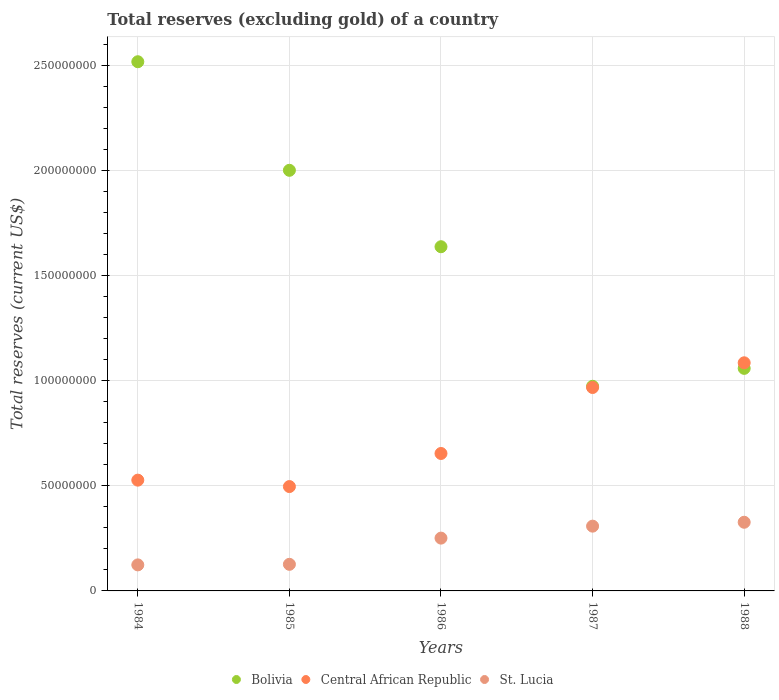How many different coloured dotlines are there?
Offer a very short reply. 3. Is the number of dotlines equal to the number of legend labels?
Your answer should be compact. Yes. What is the total reserves (excluding gold) in St. Lucia in 1987?
Offer a very short reply. 3.08e+07. Across all years, what is the maximum total reserves (excluding gold) in Bolivia?
Your response must be concise. 2.52e+08. Across all years, what is the minimum total reserves (excluding gold) in Bolivia?
Your answer should be very brief. 9.73e+07. In which year was the total reserves (excluding gold) in St. Lucia maximum?
Offer a terse response. 1988. What is the total total reserves (excluding gold) in Central African Republic in the graph?
Give a very brief answer. 3.73e+08. What is the difference between the total reserves (excluding gold) in St. Lucia in 1985 and that in 1986?
Offer a terse response. -1.25e+07. What is the difference between the total reserves (excluding gold) in St. Lucia in 1985 and the total reserves (excluding gold) in Bolivia in 1987?
Your answer should be compact. -8.47e+07. What is the average total reserves (excluding gold) in Central African Republic per year?
Provide a succinct answer. 7.46e+07. In the year 1987, what is the difference between the total reserves (excluding gold) in Bolivia and total reserves (excluding gold) in St. Lucia?
Your answer should be very brief. 6.65e+07. What is the ratio of the total reserves (excluding gold) in Central African Republic in 1984 to that in 1988?
Make the answer very short. 0.49. Is the total reserves (excluding gold) in Bolivia in 1984 less than that in 1988?
Keep it short and to the point. No. Is the difference between the total reserves (excluding gold) in Bolivia in 1984 and 1986 greater than the difference between the total reserves (excluding gold) in St. Lucia in 1984 and 1986?
Keep it short and to the point. Yes. What is the difference between the highest and the second highest total reserves (excluding gold) in Central African Republic?
Your answer should be very brief. 1.17e+07. What is the difference between the highest and the lowest total reserves (excluding gold) in St. Lucia?
Ensure brevity in your answer.  2.03e+07. Is the sum of the total reserves (excluding gold) in Bolivia in 1984 and 1987 greater than the maximum total reserves (excluding gold) in St. Lucia across all years?
Offer a very short reply. Yes. Is the total reserves (excluding gold) in Central African Republic strictly less than the total reserves (excluding gold) in Bolivia over the years?
Make the answer very short. No. Where does the legend appear in the graph?
Provide a succinct answer. Bottom center. How many legend labels are there?
Your response must be concise. 3. What is the title of the graph?
Ensure brevity in your answer.  Total reserves (excluding gold) of a country. What is the label or title of the X-axis?
Your response must be concise. Years. What is the label or title of the Y-axis?
Give a very brief answer. Total reserves (current US$). What is the Total reserves (current US$) of Bolivia in 1984?
Offer a very short reply. 2.52e+08. What is the Total reserves (current US$) of Central African Republic in 1984?
Offer a very short reply. 5.27e+07. What is the Total reserves (current US$) in St. Lucia in 1984?
Ensure brevity in your answer.  1.24e+07. What is the Total reserves (current US$) of Bolivia in 1985?
Make the answer very short. 2.00e+08. What is the Total reserves (current US$) of Central African Republic in 1985?
Offer a terse response. 4.96e+07. What is the Total reserves (current US$) in St. Lucia in 1985?
Your answer should be compact. 1.26e+07. What is the Total reserves (current US$) of Bolivia in 1986?
Make the answer very short. 1.64e+08. What is the Total reserves (current US$) in Central African Republic in 1986?
Give a very brief answer. 6.54e+07. What is the Total reserves (current US$) in St. Lucia in 1986?
Your answer should be very brief. 2.51e+07. What is the Total reserves (current US$) in Bolivia in 1987?
Your answer should be very brief. 9.73e+07. What is the Total reserves (current US$) in Central African Republic in 1987?
Give a very brief answer. 9.67e+07. What is the Total reserves (current US$) of St. Lucia in 1987?
Your answer should be very brief. 3.08e+07. What is the Total reserves (current US$) of Bolivia in 1988?
Make the answer very short. 1.06e+08. What is the Total reserves (current US$) of Central African Republic in 1988?
Provide a succinct answer. 1.08e+08. What is the Total reserves (current US$) in St. Lucia in 1988?
Provide a succinct answer. 3.26e+07. Across all years, what is the maximum Total reserves (current US$) in Bolivia?
Give a very brief answer. 2.52e+08. Across all years, what is the maximum Total reserves (current US$) in Central African Republic?
Provide a succinct answer. 1.08e+08. Across all years, what is the maximum Total reserves (current US$) in St. Lucia?
Your response must be concise. 3.26e+07. Across all years, what is the minimum Total reserves (current US$) of Bolivia?
Your answer should be compact. 9.73e+07. Across all years, what is the minimum Total reserves (current US$) of Central African Republic?
Offer a very short reply. 4.96e+07. Across all years, what is the minimum Total reserves (current US$) of St. Lucia?
Make the answer very short. 1.24e+07. What is the total Total reserves (current US$) of Bolivia in the graph?
Your answer should be very brief. 8.18e+08. What is the total Total reserves (current US$) in Central African Republic in the graph?
Your answer should be very brief. 3.73e+08. What is the total Total reserves (current US$) of St. Lucia in the graph?
Provide a succinct answer. 1.14e+08. What is the difference between the Total reserves (current US$) of Bolivia in 1984 and that in 1985?
Give a very brief answer. 5.16e+07. What is the difference between the Total reserves (current US$) in Central African Republic in 1984 and that in 1985?
Offer a terse response. 3.05e+06. What is the difference between the Total reserves (current US$) in St. Lucia in 1984 and that in 1985?
Your response must be concise. -2.70e+05. What is the difference between the Total reserves (current US$) of Bolivia in 1984 and that in 1986?
Offer a terse response. 8.80e+07. What is the difference between the Total reserves (current US$) in Central African Republic in 1984 and that in 1986?
Ensure brevity in your answer.  -1.27e+07. What is the difference between the Total reserves (current US$) of St. Lucia in 1984 and that in 1986?
Make the answer very short. -1.27e+07. What is the difference between the Total reserves (current US$) of Bolivia in 1984 and that in 1987?
Offer a very short reply. 1.54e+08. What is the difference between the Total reserves (current US$) of Central African Republic in 1984 and that in 1987?
Offer a very short reply. -4.41e+07. What is the difference between the Total reserves (current US$) in St. Lucia in 1984 and that in 1987?
Offer a terse response. -1.84e+07. What is the difference between the Total reserves (current US$) in Bolivia in 1984 and that in 1988?
Offer a very short reply. 1.46e+08. What is the difference between the Total reserves (current US$) in Central African Republic in 1984 and that in 1988?
Your response must be concise. -5.58e+07. What is the difference between the Total reserves (current US$) in St. Lucia in 1984 and that in 1988?
Offer a terse response. -2.03e+07. What is the difference between the Total reserves (current US$) in Bolivia in 1985 and that in 1986?
Ensure brevity in your answer.  3.63e+07. What is the difference between the Total reserves (current US$) of Central African Republic in 1985 and that in 1986?
Offer a very short reply. -1.57e+07. What is the difference between the Total reserves (current US$) of St. Lucia in 1985 and that in 1986?
Your response must be concise. -1.25e+07. What is the difference between the Total reserves (current US$) of Bolivia in 1985 and that in 1987?
Your answer should be compact. 1.03e+08. What is the difference between the Total reserves (current US$) in Central African Republic in 1985 and that in 1987?
Keep it short and to the point. -4.71e+07. What is the difference between the Total reserves (current US$) in St. Lucia in 1985 and that in 1987?
Ensure brevity in your answer.  -1.82e+07. What is the difference between the Total reserves (current US$) of Bolivia in 1985 and that in 1988?
Keep it short and to the point. 9.42e+07. What is the difference between the Total reserves (current US$) in Central African Republic in 1985 and that in 1988?
Your answer should be compact. -5.89e+07. What is the difference between the Total reserves (current US$) in St. Lucia in 1985 and that in 1988?
Your answer should be very brief. -2.00e+07. What is the difference between the Total reserves (current US$) in Bolivia in 1986 and that in 1987?
Keep it short and to the point. 6.64e+07. What is the difference between the Total reserves (current US$) of Central African Republic in 1986 and that in 1987?
Offer a very short reply. -3.14e+07. What is the difference between the Total reserves (current US$) of St. Lucia in 1986 and that in 1987?
Your answer should be very brief. -5.69e+06. What is the difference between the Total reserves (current US$) of Bolivia in 1986 and that in 1988?
Offer a very short reply. 5.78e+07. What is the difference between the Total reserves (current US$) of Central African Republic in 1986 and that in 1988?
Ensure brevity in your answer.  -4.31e+07. What is the difference between the Total reserves (current US$) in St. Lucia in 1986 and that in 1988?
Provide a short and direct response. -7.54e+06. What is the difference between the Total reserves (current US$) in Bolivia in 1987 and that in 1988?
Offer a very short reply. -8.51e+06. What is the difference between the Total reserves (current US$) of Central African Republic in 1987 and that in 1988?
Make the answer very short. -1.17e+07. What is the difference between the Total reserves (current US$) of St. Lucia in 1987 and that in 1988?
Provide a succinct answer. -1.85e+06. What is the difference between the Total reserves (current US$) in Bolivia in 1984 and the Total reserves (current US$) in Central African Republic in 1985?
Give a very brief answer. 2.02e+08. What is the difference between the Total reserves (current US$) of Bolivia in 1984 and the Total reserves (current US$) of St. Lucia in 1985?
Your response must be concise. 2.39e+08. What is the difference between the Total reserves (current US$) in Central African Republic in 1984 and the Total reserves (current US$) in St. Lucia in 1985?
Your response must be concise. 4.00e+07. What is the difference between the Total reserves (current US$) of Bolivia in 1984 and the Total reserves (current US$) of Central African Republic in 1986?
Keep it short and to the point. 1.86e+08. What is the difference between the Total reserves (current US$) of Bolivia in 1984 and the Total reserves (current US$) of St. Lucia in 1986?
Offer a very short reply. 2.27e+08. What is the difference between the Total reserves (current US$) in Central African Republic in 1984 and the Total reserves (current US$) in St. Lucia in 1986?
Provide a succinct answer. 2.76e+07. What is the difference between the Total reserves (current US$) in Bolivia in 1984 and the Total reserves (current US$) in Central African Republic in 1987?
Your response must be concise. 1.55e+08. What is the difference between the Total reserves (current US$) of Bolivia in 1984 and the Total reserves (current US$) of St. Lucia in 1987?
Give a very brief answer. 2.21e+08. What is the difference between the Total reserves (current US$) in Central African Republic in 1984 and the Total reserves (current US$) in St. Lucia in 1987?
Give a very brief answer. 2.19e+07. What is the difference between the Total reserves (current US$) in Bolivia in 1984 and the Total reserves (current US$) in Central African Republic in 1988?
Offer a very short reply. 1.43e+08. What is the difference between the Total reserves (current US$) in Bolivia in 1984 and the Total reserves (current US$) in St. Lucia in 1988?
Ensure brevity in your answer.  2.19e+08. What is the difference between the Total reserves (current US$) of Central African Republic in 1984 and the Total reserves (current US$) of St. Lucia in 1988?
Keep it short and to the point. 2.00e+07. What is the difference between the Total reserves (current US$) in Bolivia in 1985 and the Total reserves (current US$) in Central African Republic in 1986?
Your answer should be compact. 1.35e+08. What is the difference between the Total reserves (current US$) in Bolivia in 1985 and the Total reserves (current US$) in St. Lucia in 1986?
Your answer should be very brief. 1.75e+08. What is the difference between the Total reserves (current US$) in Central African Republic in 1985 and the Total reserves (current US$) in St. Lucia in 1986?
Offer a very short reply. 2.45e+07. What is the difference between the Total reserves (current US$) in Bolivia in 1985 and the Total reserves (current US$) in Central African Republic in 1987?
Give a very brief answer. 1.03e+08. What is the difference between the Total reserves (current US$) of Bolivia in 1985 and the Total reserves (current US$) of St. Lucia in 1987?
Your answer should be very brief. 1.69e+08. What is the difference between the Total reserves (current US$) of Central African Republic in 1985 and the Total reserves (current US$) of St. Lucia in 1987?
Give a very brief answer. 1.88e+07. What is the difference between the Total reserves (current US$) of Bolivia in 1985 and the Total reserves (current US$) of Central African Republic in 1988?
Give a very brief answer. 9.15e+07. What is the difference between the Total reserves (current US$) of Bolivia in 1985 and the Total reserves (current US$) of St. Lucia in 1988?
Offer a very short reply. 1.67e+08. What is the difference between the Total reserves (current US$) of Central African Republic in 1985 and the Total reserves (current US$) of St. Lucia in 1988?
Make the answer very short. 1.70e+07. What is the difference between the Total reserves (current US$) in Bolivia in 1986 and the Total reserves (current US$) in Central African Republic in 1987?
Provide a short and direct response. 6.69e+07. What is the difference between the Total reserves (current US$) of Bolivia in 1986 and the Total reserves (current US$) of St. Lucia in 1987?
Ensure brevity in your answer.  1.33e+08. What is the difference between the Total reserves (current US$) of Central African Republic in 1986 and the Total reserves (current US$) of St. Lucia in 1987?
Your response must be concise. 3.46e+07. What is the difference between the Total reserves (current US$) in Bolivia in 1986 and the Total reserves (current US$) in Central African Republic in 1988?
Provide a succinct answer. 5.52e+07. What is the difference between the Total reserves (current US$) of Bolivia in 1986 and the Total reserves (current US$) of St. Lucia in 1988?
Give a very brief answer. 1.31e+08. What is the difference between the Total reserves (current US$) of Central African Republic in 1986 and the Total reserves (current US$) of St. Lucia in 1988?
Offer a very short reply. 3.27e+07. What is the difference between the Total reserves (current US$) in Bolivia in 1987 and the Total reserves (current US$) in Central African Republic in 1988?
Provide a short and direct response. -1.12e+07. What is the difference between the Total reserves (current US$) of Bolivia in 1987 and the Total reserves (current US$) of St. Lucia in 1988?
Make the answer very short. 6.47e+07. What is the difference between the Total reserves (current US$) in Central African Republic in 1987 and the Total reserves (current US$) in St. Lucia in 1988?
Offer a terse response. 6.41e+07. What is the average Total reserves (current US$) of Bolivia per year?
Make the answer very short. 1.64e+08. What is the average Total reserves (current US$) of Central African Republic per year?
Keep it short and to the point. 7.46e+07. What is the average Total reserves (current US$) in St. Lucia per year?
Keep it short and to the point. 2.27e+07. In the year 1984, what is the difference between the Total reserves (current US$) of Bolivia and Total reserves (current US$) of Central African Republic?
Keep it short and to the point. 1.99e+08. In the year 1984, what is the difference between the Total reserves (current US$) of Bolivia and Total reserves (current US$) of St. Lucia?
Give a very brief answer. 2.39e+08. In the year 1984, what is the difference between the Total reserves (current US$) in Central African Republic and Total reserves (current US$) in St. Lucia?
Provide a short and direct response. 4.03e+07. In the year 1985, what is the difference between the Total reserves (current US$) in Bolivia and Total reserves (current US$) in Central African Republic?
Provide a succinct answer. 1.50e+08. In the year 1985, what is the difference between the Total reserves (current US$) in Bolivia and Total reserves (current US$) in St. Lucia?
Your answer should be compact. 1.87e+08. In the year 1985, what is the difference between the Total reserves (current US$) of Central African Republic and Total reserves (current US$) of St. Lucia?
Provide a succinct answer. 3.70e+07. In the year 1986, what is the difference between the Total reserves (current US$) of Bolivia and Total reserves (current US$) of Central African Republic?
Your answer should be very brief. 9.83e+07. In the year 1986, what is the difference between the Total reserves (current US$) in Bolivia and Total reserves (current US$) in St. Lucia?
Your answer should be compact. 1.39e+08. In the year 1986, what is the difference between the Total reserves (current US$) of Central African Republic and Total reserves (current US$) of St. Lucia?
Your answer should be compact. 4.02e+07. In the year 1987, what is the difference between the Total reserves (current US$) in Bolivia and Total reserves (current US$) in Central African Republic?
Make the answer very short. 5.87e+05. In the year 1987, what is the difference between the Total reserves (current US$) of Bolivia and Total reserves (current US$) of St. Lucia?
Provide a short and direct response. 6.65e+07. In the year 1987, what is the difference between the Total reserves (current US$) of Central African Republic and Total reserves (current US$) of St. Lucia?
Your answer should be compact. 6.59e+07. In the year 1988, what is the difference between the Total reserves (current US$) of Bolivia and Total reserves (current US$) of Central African Republic?
Keep it short and to the point. -2.65e+06. In the year 1988, what is the difference between the Total reserves (current US$) of Bolivia and Total reserves (current US$) of St. Lucia?
Make the answer very short. 7.32e+07. In the year 1988, what is the difference between the Total reserves (current US$) in Central African Republic and Total reserves (current US$) in St. Lucia?
Provide a short and direct response. 7.58e+07. What is the ratio of the Total reserves (current US$) in Bolivia in 1984 to that in 1985?
Your answer should be compact. 1.26. What is the ratio of the Total reserves (current US$) in Central African Republic in 1984 to that in 1985?
Offer a terse response. 1.06. What is the ratio of the Total reserves (current US$) in St. Lucia in 1984 to that in 1985?
Make the answer very short. 0.98. What is the ratio of the Total reserves (current US$) in Bolivia in 1984 to that in 1986?
Your response must be concise. 1.54. What is the ratio of the Total reserves (current US$) in Central African Republic in 1984 to that in 1986?
Offer a terse response. 0.81. What is the ratio of the Total reserves (current US$) of St. Lucia in 1984 to that in 1986?
Provide a succinct answer. 0.49. What is the ratio of the Total reserves (current US$) of Bolivia in 1984 to that in 1987?
Keep it short and to the point. 2.59. What is the ratio of the Total reserves (current US$) in Central African Republic in 1984 to that in 1987?
Ensure brevity in your answer.  0.54. What is the ratio of the Total reserves (current US$) of St. Lucia in 1984 to that in 1987?
Offer a terse response. 0.4. What is the ratio of the Total reserves (current US$) in Bolivia in 1984 to that in 1988?
Provide a short and direct response. 2.38. What is the ratio of the Total reserves (current US$) of Central African Republic in 1984 to that in 1988?
Offer a very short reply. 0.49. What is the ratio of the Total reserves (current US$) in St. Lucia in 1984 to that in 1988?
Make the answer very short. 0.38. What is the ratio of the Total reserves (current US$) of Bolivia in 1985 to that in 1986?
Provide a succinct answer. 1.22. What is the ratio of the Total reserves (current US$) in Central African Republic in 1985 to that in 1986?
Provide a succinct answer. 0.76. What is the ratio of the Total reserves (current US$) of St. Lucia in 1985 to that in 1986?
Offer a very short reply. 0.5. What is the ratio of the Total reserves (current US$) in Bolivia in 1985 to that in 1987?
Give a very brief answer. 2.06. What is the ratio of the Total reserves (current US$) of Central African Republic in 1985 to that in 1987?
Give a very brief answer. 0.51. What is the ratio of the Total reserves (current US$) in St. Lucia in 1985 to that in 1987?
Offer a very short reply. 0.41. What is the ratio of the Total reserves (current US$) of Bolivia in 1985 to that in 1988?
Your answer should be very brief. 1.89. What is the ratio of the Total reserves (current US$) in Central African Republic in 1985 to that in 1988?
Your answer should be very brief. 0.46. What is the ratio of the Total reserves (current US$) in St. Lucia in 1985 to that in 1988?
Offer a very short reply. 0.39. What is the ratio of the Total reserves (current US$) of Bolivia in 1986 to that in 1987?
Offer a very short reply. 1.68. What is the ratio of the Total reserves (current US$) in Central African Republic in 1986 to that in 1987?
Ensure brevity in your answer.  0.68. What is the ratio of the Total reserves (current US$) of St. Lucia in 1986 to that in 1987?
Provide a short and direct response. 0.82. What is the ratio of the Total reserves (current US$) of Bolivia in 1986 to that in 1988?
Give a very brief answer. 1.55. What is the ratio of the Total reserves (current US$) of Central African Republic in 1986 to that in 1988?
Your answer should be compact. 0.6. What is the ratio of the Total reserves (current US$) in St. Lucia in 1986 to that in 1988?
Offer a terse response. 0.77. What is the ratio of the Total reserves (current US$) in Bolivia in 1987 to that in 1988?
Offer a very short reply. 0.92. What is the ratio of the Total reserves (current US$) of Central African Republic in 1987 to that in 1988?
Keep it short and to the point. 0.89. What is the ratio of the Total reserves (current US$) of St. Lucia in 1987 to that in 1988?
Provide a short and direct response. 0.94. What is the difference between the highest and the second highest Total reserves (current US$) in Bolivia?
Keep it short and to the point. 5.16e+07. What is the difference between the highest and the second highest Total reserves (current US$) in Central African Republic?
Your answer should be compact. 1.17e+07. What is the difference between the highest and the second highest Total reserves (current US$) of St. Lucia?
Provide a short and direct response. 1.85e+06. What is the difference between the highest and the lowest Total reserves (current US$) of Bolivia?
Offer a very short reply. 1.54e+08. What is the difference between the highest and the lowest Total reserves (current US$) of Central African Republic?
Offer a terse response. 5.89e+07. What is the difference between the highest and the lowest Total reserves (current US$) of St. Lucia?
Provide a succinct answer. 2.03e+07. 